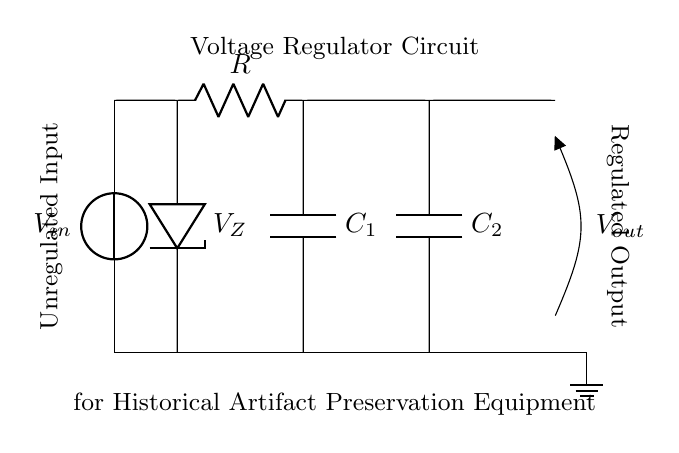What is the type of voltage regulation used in this circuit? The circuit employs a Zener diode for voltage regulation, which provides a stable output voltage despite variations in input voltage.
Answer: Zener diode What components are present in this voltage regulator circuit? The components include a Zener diode, a resistor, and two capacitors that support the stability and filtering of the output.
Answer: Zener diode, resistor, capacitors What is the purpose of the resistor in this circuit? The resistor is used to limit the current flowing through the Zener diode to prevent it from exceeding its maximum rating, thus ensuring safe operation.
Answer: Current limit What is the output voltage denoted as in this circuit? The output voltage is indicated as V out on the circuit diagram, representing the regulated voltage supplied to the preservation equipment.
Answer: V out How do the capacitors contribute to this circuit's functionality? The capacitors are used for smoothing the output voltage and stabilizing the circuit by reducing voltage ripple, which enhances the performance of the connected equipment.
Answer: Smoothing and stabilization What would happen if the input voltage decreased significantly? If the input voltage falls below the Zener voltage, the output voltage will also decrease, leading to inadequate regulation and potential malfunction of connected devices.
Answer: Decreased output voltage Why is this circuit specifically suitable for historical artifact preservation equipment? This circuit ensures a stable and reliable voltage supply, which is crucial for preserving sensitive historical artifacts that may be affected by voltage fluctuations.
Answer: Stable voltage supply 